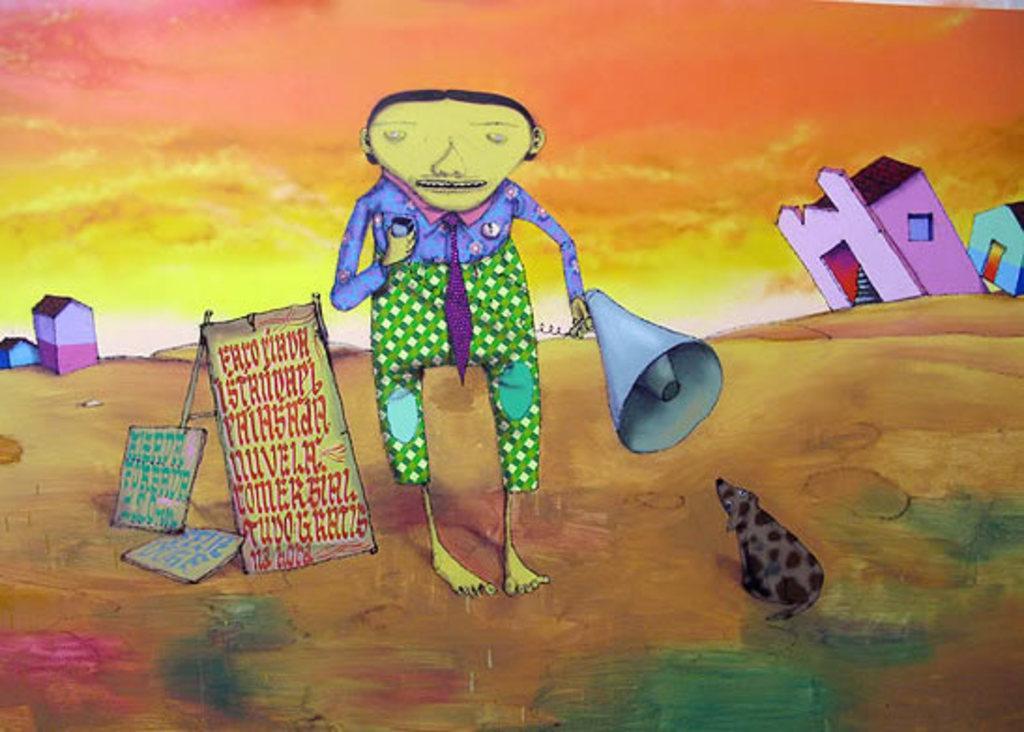Please provide a concise description of this image. There is an animated image, where we can see a person, posters and houses. 